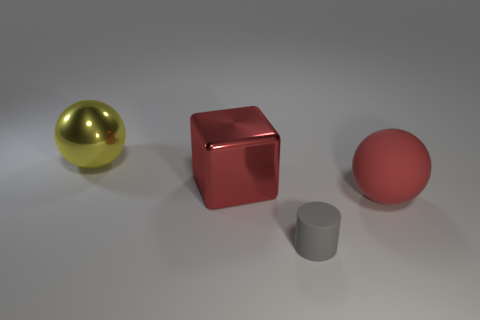Add 3 big yellow shiny objects. How many objects exist? 7 Subtract 0 purple balls. How many objects are left? 4 Subtract all cubes. How many objects are left? 3 Subtract 1 cylinders. How many cylinders are left? 0 Subtract all blue spheres. Subtract all cyan blocks. How many spheres are left? 2 Subtract all gray cylinders. How many red spheres are left? 1 Subtract all big shiny objects. Subtract all red things. How many objects are left? 0 Add 3 tiny gray matte things. How many tiny gray matte things are left? 4 Add 4 large red things. How many large red things exist? 6 Subtract all yellow spheres. How many spheres are left? 1 